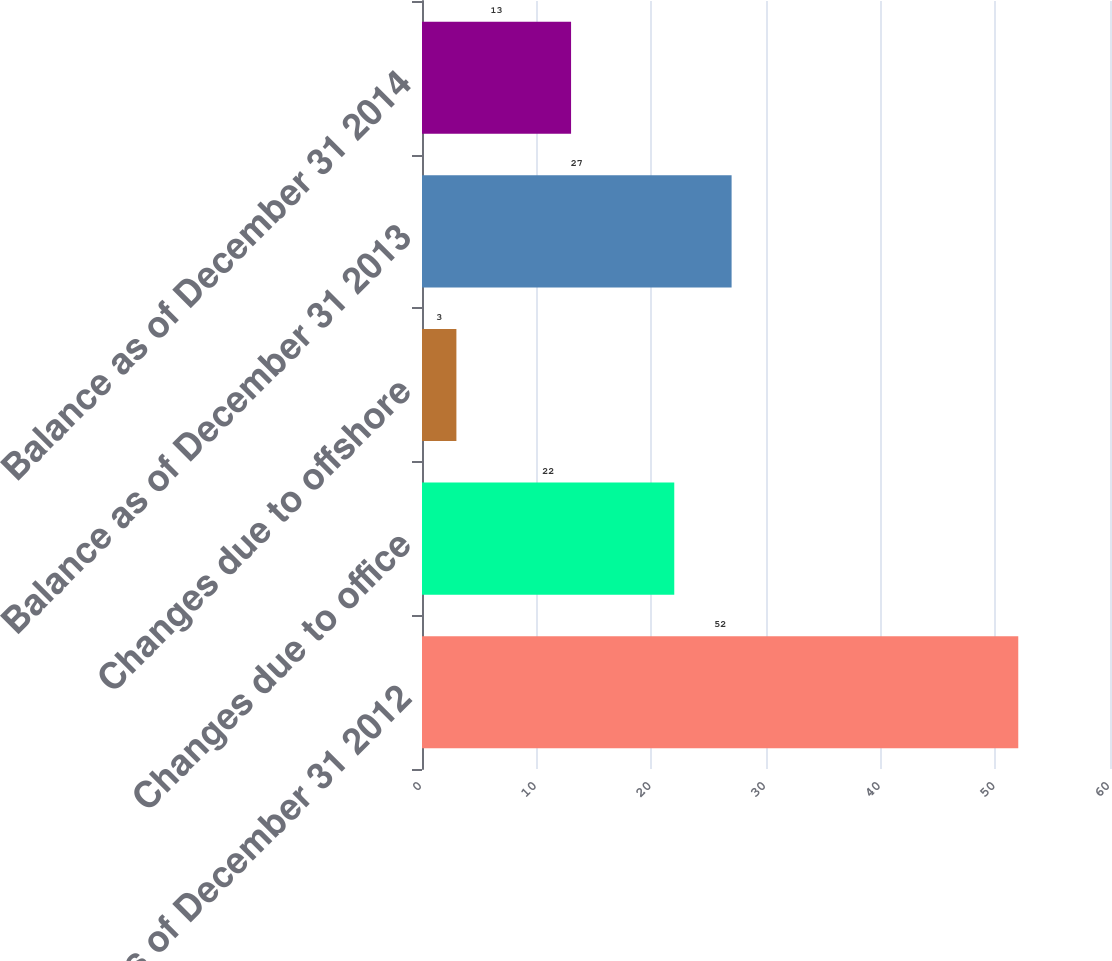Convert chart. <chart><loc_0><loc_0><loc_500><loc_500><bar_chart><fcel>Balance as of December 31 2012<fcel>Changes due to office<fcel>Changes due to offshore<fcel>Balance as of December 31 2013<fcel>Balance as of December 31 2014<nl><fcel>52<fcel>22<fcel>3<fcel>27<fcel>13<nl></chart> 